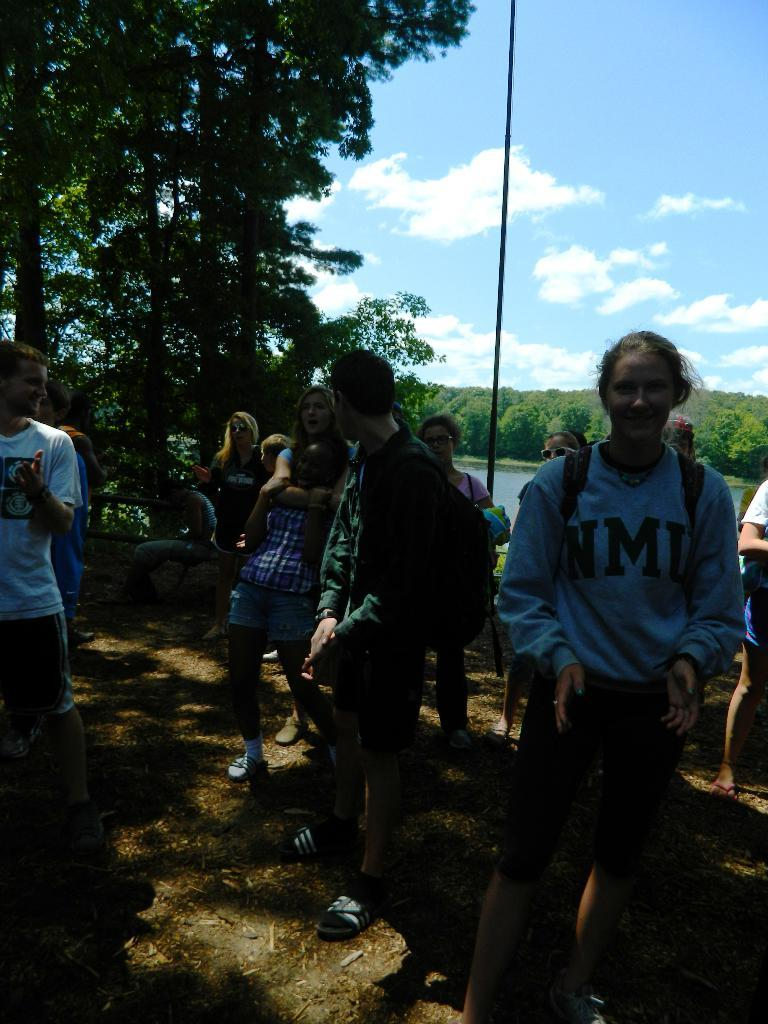How many people are in the image? There is a group of people in the image, but the exact number is not specified. What are the people wearing in the image? The people are wearing bags in the image. What can be seen in the background of the image? There are trees and a lake in the background of the image. What is the condition of the sky in the image? The sky is clear in the image. What type of question is being asked by the glove in the image? There is no glove present in the image, and therefore no question is being asked. What toys can be seen in the hands of the people in the image? There is no mention of toys in the image; the people are wearing bags. 